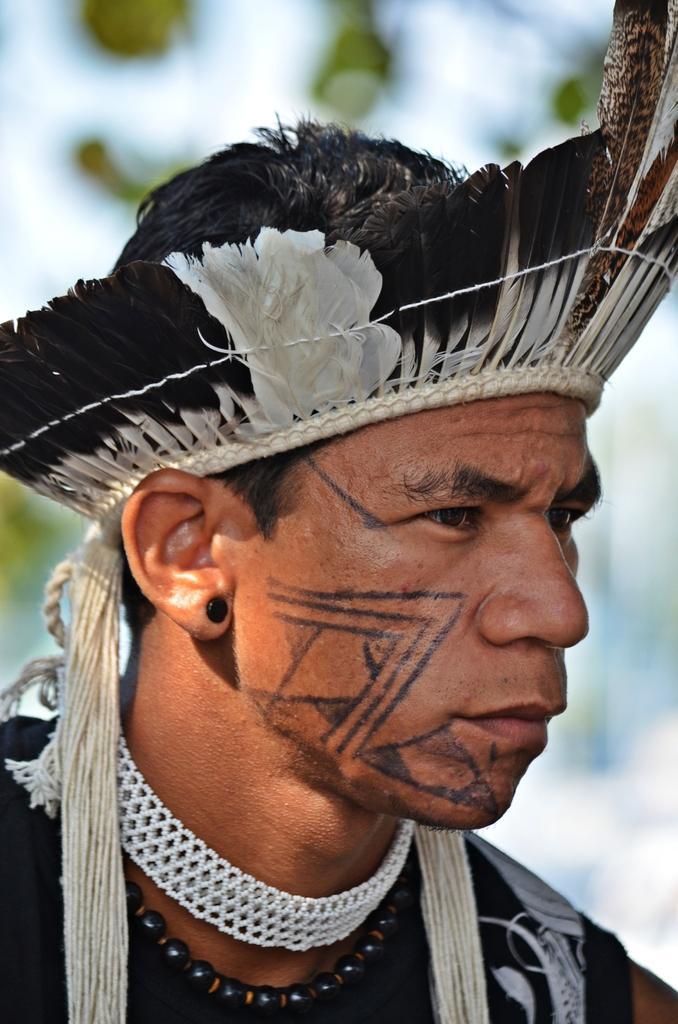Describe this image in one or two sentences. In this image, we can see a man wearing feather hat. 